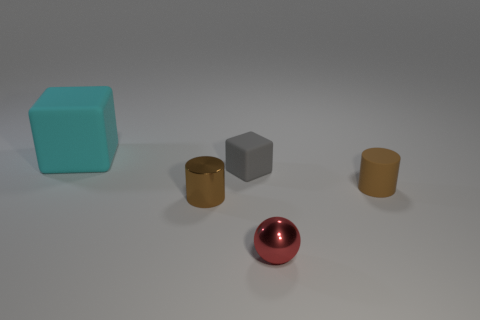Add 1 big purple cylinders. How many objects exist? 6 Subtract all cyan rubber cubes. Subtract all large matte objects. How many objects are left? 3 Add 5 brown rubber cylinders. How many brown rubber cylinders are left? 6 Add 2 large cyan rubber objects. How many large cyan rubber objects exist? 3 Subtract 0 brown blocks. How many objects are left? 5 Subtract all cylinders. How many objects are left? 3 